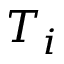Convert formula to latex. <formula><loc_0><loc_0><loc_500><loc_500>T _ { i }</formula> 